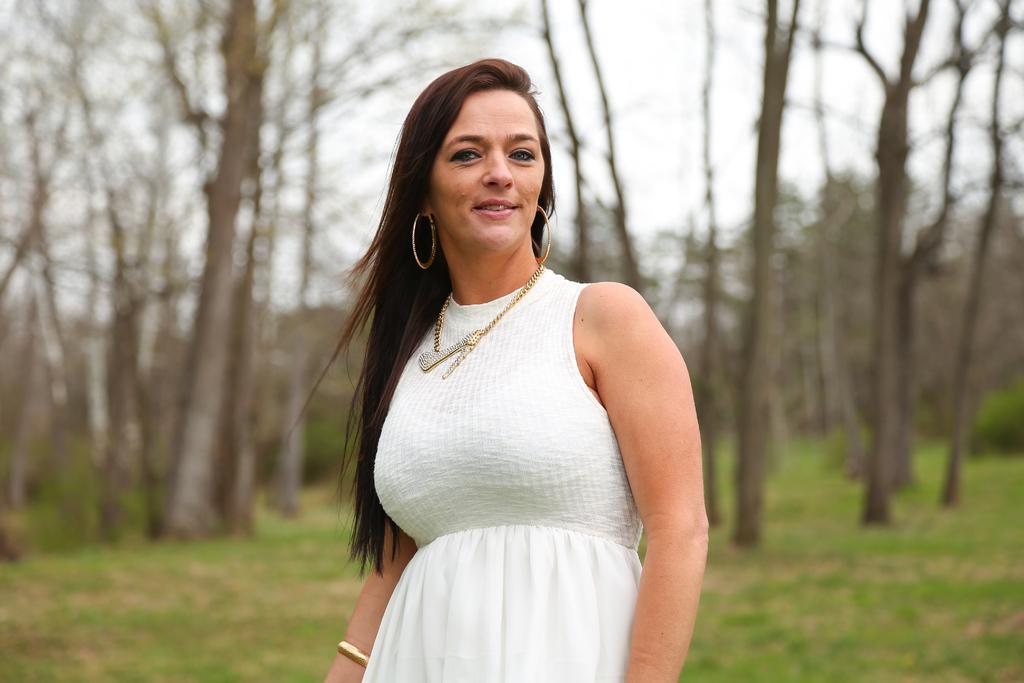Can you describe this image briefly? In this image we can see one woman in white dress standing on the ground, some trees, bushes, green grass on the ground and at the top there is the sky. 